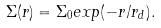Convert formula to latex. <formula><loc_0><loc_0><loc_500><loc_500>\Sigma ( r ) = \Sigma _ { 0 } e x p ( - r / r _ { d } ) .</formula> 